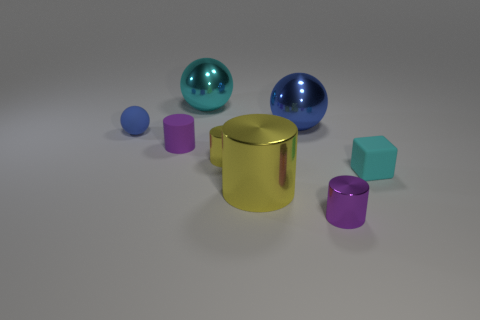Subtract all brown cylinders. Subtract all yellow blocks. How many cylinders are left? 4 Add 2 tiny red metal spheres. How many objects exist? 10 Subtract all balls. How many objects are left? 5 Add 6 tiny blue spheres. How many tiny blue spheres are left? 7 Add 8 big brown metallic balls. How many big brown metallic balls exist? 8 Subtract 1 cyan balls. How many objects are left? 7 Subtract all matte cubes. Subtract all tiny blue matte balls. How many objects are left? 6 